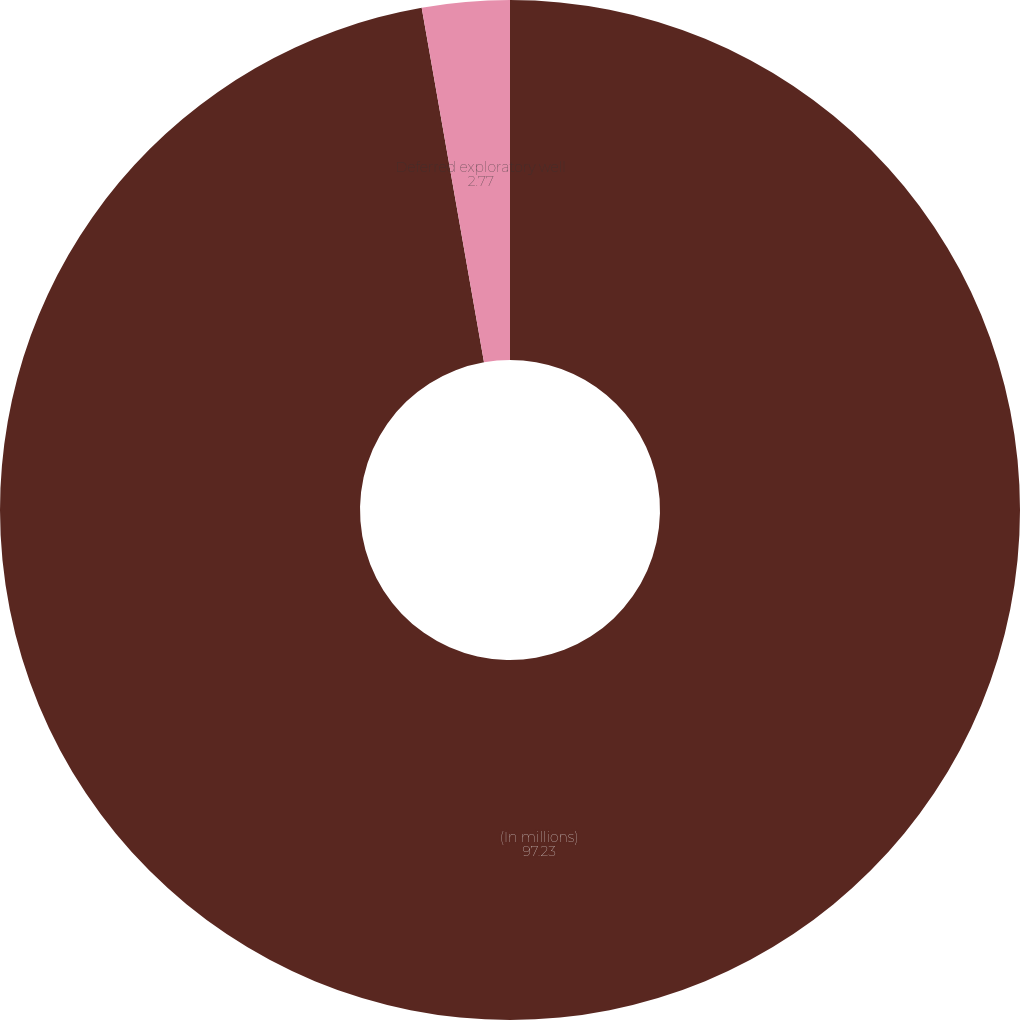<chart> <loc_0><loc_0><loc_500><loc_500><pie_chart><fcel>(In millions)<fcel>Deferred exploratory well<nl><fcel>97.23%<fcel>2.77%<nl></chart> 